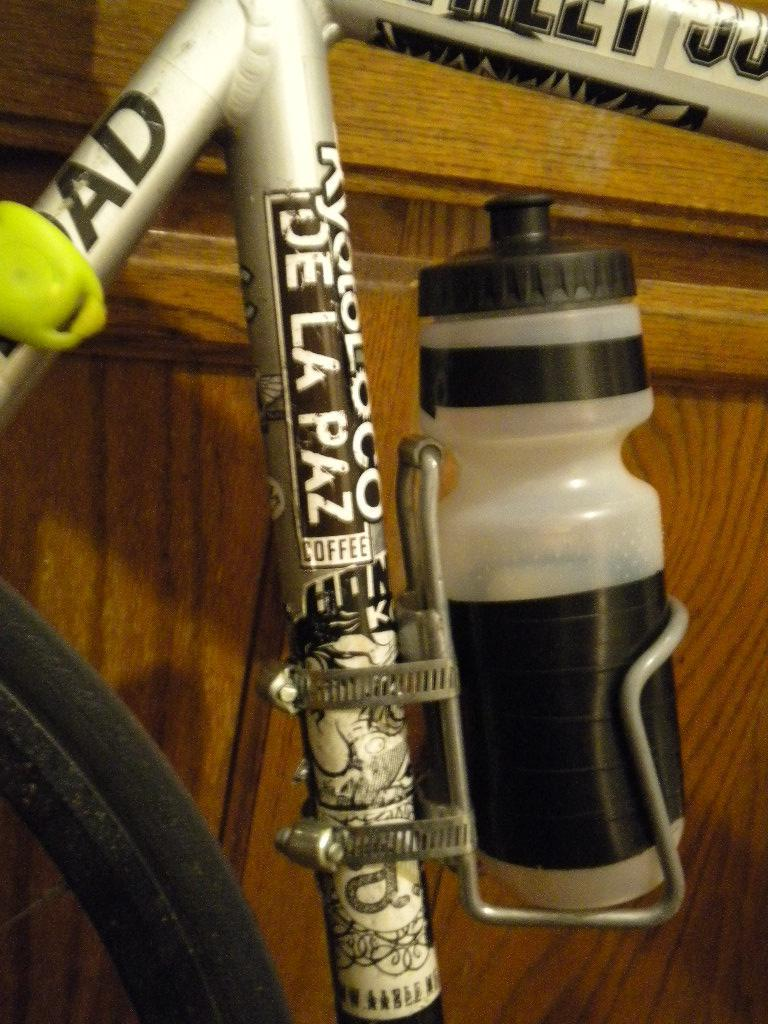What type of vehicle is partially visible in the image? There is a part of a cycle in the image. What object can be seen besides the cycle? There is a bottle in the image. What type of architectural feature is visible in the background of the image? There is a wooden door in the background of the image. What type of learning is taking place in the hospital during this week in the image? There is no indication of learning, a hospital, or a specific week in the image. 